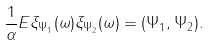Convert formula to latex. <formula><loc_0><loc_0><loc_500><loc_500>\frac { 1 } { \alpha } E \xi _ { \Psi _ { 1 } } ( \omega ) \xi _ { \Psi _ { 2 } } ( \omega ) = ( \Psi _ { 1 } , \Psi _ { 2 } ) .</formula> 